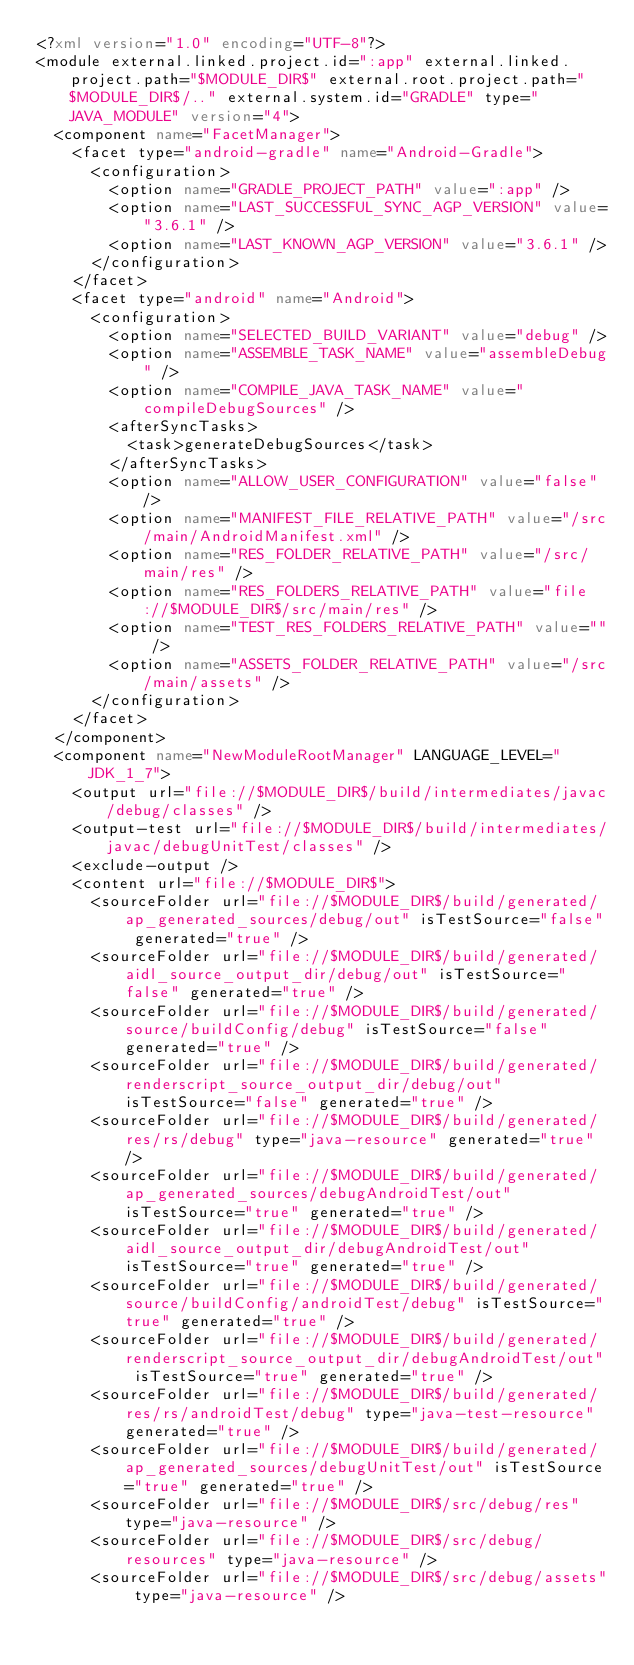Convert code to text. <code><loc_0><loc_0><loc_500><loc_500><_XML_><?xml version="1.0" encoding="UTF-8"?>
<module external.linked.project.id=":app" external.linked.project.path="$MODULE_DIR$" external.root.project.path="$MODULE_DIR$/.." external.system.id="GRADLE" type="JAVA_MODULE" version="4">
  <component name="FacetManager">
    <facet type="android-gradle" name="Android-Gradle">
      <configuration>
        <option name="GRADLE_PROJECT_PATH" value=":app" />
        <option name="LAST_SUCCESSFUL_SYNC_AGP_VERSION" value="3.6.1" />
        <option name="LAST_KNOWN_AGP_VERSION" value="3.6.1" />
      </configuration>
    </facet>
    <facet type="android" name="Android">
      <configuration>
        <option name="SELECTED_BUILD_VARIANT" value="debug" />
        <option name="ASSEMBLE_TASK_NAME" value="assembleDebug" />
        <option name="COMPILE_JAVA_TASK_NAME" value="compileDebugSources" />
        <afterSyncTasks>
          <task>generateDebugSources</task>
        </afterSyncTasks>
        <option name="ALLOW_USER_CONFIGURATION" value="false" />
        <option name="MANIFEST_FILE_RELATIVE_PATH" value="/src/main/AndroidManifest.xml" />
        <option name="RES_FOLDER_RELATIVE_PATH" value="/src/main/res" />
        <option name="RES_FOLDERS_RELATIVE_PATH" value="file://$MODULE_DIR$/src/main/res" />
        <option name="TEST_RES_FOLDERS_RELATIVE_PATH" value="" />
        <option name="ASSETS_FOLDER_RELATIVE_PATH" value="/src/main/assets" />
      </configuration>
    </facet>
  </component>
  <component name="NewModuleRootManager" LANGUAGE_LEVEL="JDK_1_7">
    <output url="file://$MODULE_DIR$/build/intermediates/javac/debug/classes" />
    <output-test url="file://$MODULE_DIR$/build/intermediates/javac/debugUnitTest/classes" />
    <exclude-output />
    <content url="file://$MODULE_DIR$">
      <sourceFolder url="file://$MODULE_DIR$/build/generated/ap_generated_sources/debug/out" isTestSource="false" generated="true" />
      <sourceFolder url="file://$MODULE_DIR$/build/generated/aidl_source_output_dir/debug/out" isTestSource="false" generated="true" />
      <sourceFolder url="file://$MODULE_DIR$/build/generated/source/buildConfig/debug" isTestSource="false" generated="true" />
      <sourceFolder url="file://$MODULE_DIR$/build/generated/renderscript_source_output_dir/debug/out" isTestSource="false" generated="true" />
      <sourceFolder url="file://$MODULE_DIR$/build/generated/res/rs/debug" type="java-resource" generated="true" />
      <sourceFolder url="file://$MODULE_DIR$/build/generated/ap_generated_sources/debugAndroidTest/out" isTestSource="true" generated="true" />
      <sourceFolder url="file://$MODULE_DIR$/build/generated/aidl_source_output_dir/debugAndroidTest/out" isTestSource="true" generated="true" />
      <sourceFolder url="file://$MODULE_DIR$/build/generated/source/buildConfig/androidTest/debug" isTestSource="true" generated="true" />
      <sourceFolder url="file://$MODULE_DIR$/build/generated/renderscript_source_output_dir/debugAndroidTest/out" isTestSource="true" generated="true" />
      <sourceFolder url="file://$MODULE_DIR$/build/generated/res/rs/androidTest/debug" type="java-test-resource" generated="true" />
      <sourceFolder url="file://$MODULE_DIR$/build/generated/ap_generated_sources/debugUnitTest/out" isTestSource="true" generated="true" />
      <sourceFolder url="file://$MODULE_DIR$/src/debug/res" type="java-resource" />
      <sourceFolder url="file://$MODULE_DIR$/src/debug/resources" type="java-resource" />
      <sourceFolder url="file://$MODULE_DIR$/src/debug/assets" type="java-resource" /></code> 